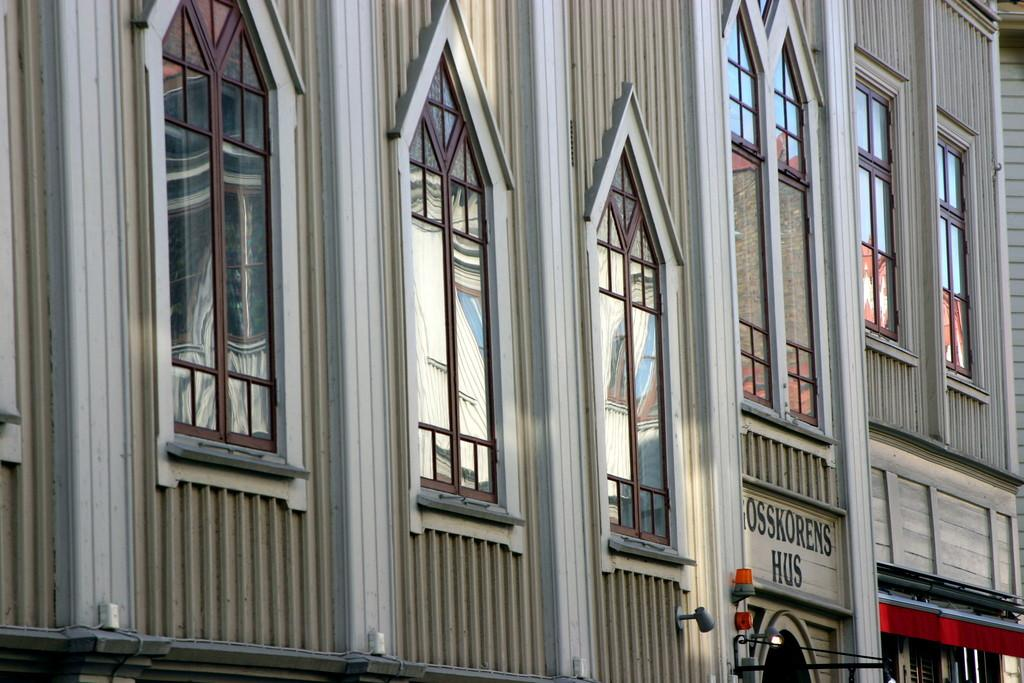What type of structure is visible in the image? There is a building in the image. Where is the throne located in the image? There is no throne present in the image; it only features a building. How many bombs can be seen in the image? There are no bombs present in the image; it only features a building. 